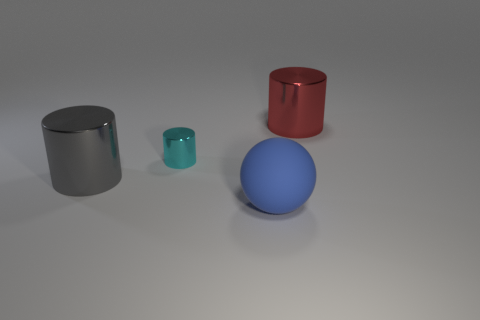Is the number of big blue spheres that are right of the red object less than the number of cyan matte blocks?
Make the answer very short. No. Is the material of the blue object the same as the large cylinder that is on the right side of the big gray cylinder?
Provide a succinct answer. No. Is there a large cylinder on the left side of the big thing that is behind the large metal object that is in front of the big red object?
Provide a succinct answer. Yes. Is there any other thing that is the same size as the gray metal thing?
Make the answer very short. Yes. The other big thing that is the same material as the red thing is what color?
Your response must be concise. Gray. What is the size of the object that is both in front of the tiny object and on the left side of the blue sphere?
Ensure brevity in your answer.  Large. Is the number of tiny things that are behind the red cylinder less than the number of large gray objects that are in front of the large matte thing?
Provide a succinct answer. No. Is the material of the cylinder that is in front of the tiny cyan object the same as the blue ball that is to the right of the tiny cyan metallic cylinder?
Provide a succinct answer. No. What is the shape of the metallic object that is both to the right of the gray cylinder and on the left side of the large red metallic thing?
Provide a short and direct response. Cylinder. There is a large blue object on the right side of the large cylinder that is left of the blue rubber ball; what is its material?
Provide a short and direct response. Rubber. 